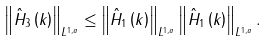Convert formula to latex. <formula><loc_0><loc_0><loc_500><loc_500>\left \| \hat { H } _ { 3 } \left ( k \right ) \right \| _ { L ^ { 1 , a } } \leq \left \| \hat { H } _ { 1 } \left ( k \right ) \right \| _ { L ^ { 1 , a } } \left \| \hat { H } _ { 1 } \left ( k \right ) \right \| _ { L ^ { 1 , a } } .</formula> 